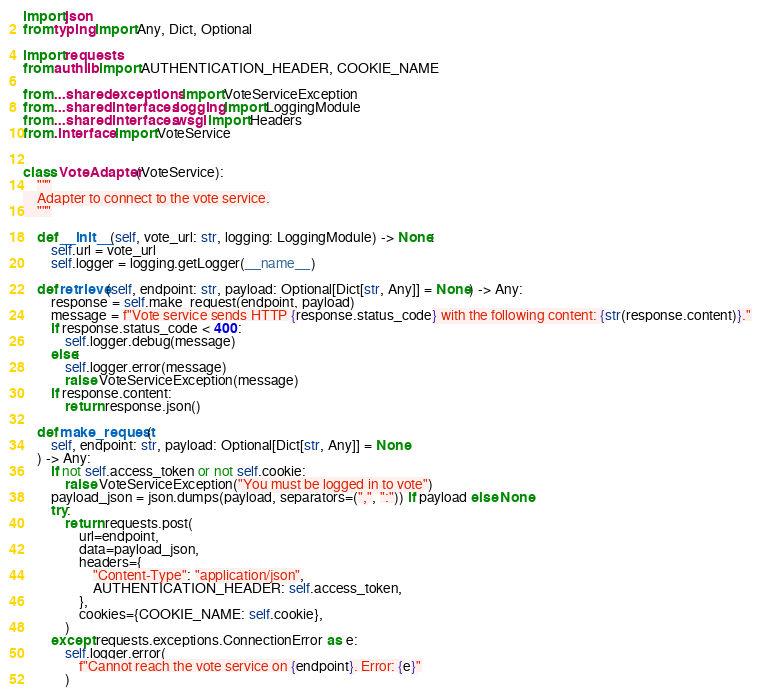<code> <loc_0><loc_0><loc_500><loc_500><_Python_>import json
from typing import Any, Dict, Optional

import requests
from authlib import AUTHENTICATION_HEADER, COOKIE_NAME

from ...shared.exceptions import VoteServiceException
from ...shared.interfaces.logging import LoggingModule
from ...shared.interfaces.wsgi import Headers
from .interface import VoteService


class VoteAdapter(VoteService):
    """
    Adapter to connect to the vote service.
    """

    def __init__(self, vote_url: str, logging: LoggingModule) -> None:
        self.url = vote_url
        self.logger = logging.getLogger(__name__)

    def retrieve(self, endpoint: str, payload: Optional[Dict[str, Any]] = None) -> Any:
        response = self.make_request(endpoint, payload)
        message = f"Vote service sends HTTP {response.status_code} with the following content: {str(response.content)}."
        if response.status_code < 400:
            self.logger.debug(message)
        else:
            self.logger.error(message)
            raise VoteServiceException(message)
        if response.content:
            return response.json()

    def make_request(
        self, endpoint: str, payload: Optional[Dict[str, Any]] = None
    ) -> Any:
        if not self.access_token or not self.cookie:
            raise VoteServiceException("You must be logged in to vote")
        payload_json = json.dumps(payload, separators=(",", ":")) if payload else None
        try:
            return requests.post(
                url=endpoint,
                data=payload_json,
                headers={
                    "Content-Type": "application/json",
                    AUTHENTICATION_HEADER: self.access_token,
                },
                cookies={COOKIE_NAME: self.cookie},
            )
        except requests.exceptions.ConnectionError as e:
            self.logger.error(
                f"Cannot reach the vote service on {endpoint}. Error: {e}"
            )</code> 